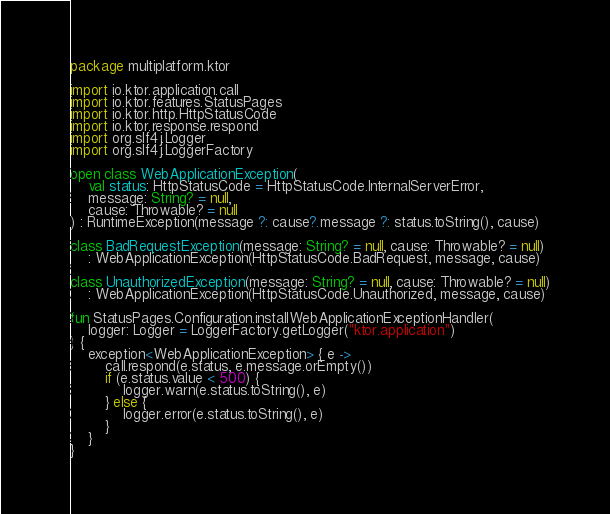Convert code to text. <code><loc_0><loc_0><loc_500><loc_500><_Kotlin_>package multiplatform.ktor

import io.ktor.application.call
import io.ktor.features.StatusPages
import io.ktor.http.HttpStatusCode
import io.ktor.response.respond
import org.slf4j.Logger
import org.slf4j.LoggerFactory

open class WebApplicationException(
    val status: HttpStatusCode = HttpStatusCode.InternalServerError,
    message: String? = null,
    cause: Throwable? = null
) : RuntimeException(message ?: cause?.message ?: status.toString(), cause)

class BadRequestException(message: String? = null, cause: Throwable? = null)
    : WebApplicationException(HttpStatusCode.BadRequest, message, cause)

class UnauthorizedException(message: String? = null, cause: Throwable? = null)
    : WebApplicationException(HttpStatusCode.Unauthorized, message, cause)

fun StatusPages.Configuration.installWebApplicationExceptionHandler(
    logger: Logger = LoggerFactory.getLogger("ktor.application")
) {
    exception<WebApplicationException> { e ->
        call.respond(e.status, e.message.orEmpty())
        if (e.status.value < 500) {
            logger.warn(e.status.toString(), e)
        } else {
            logger.error(e.status.toString(), e)
        }
    }
}
</code> 